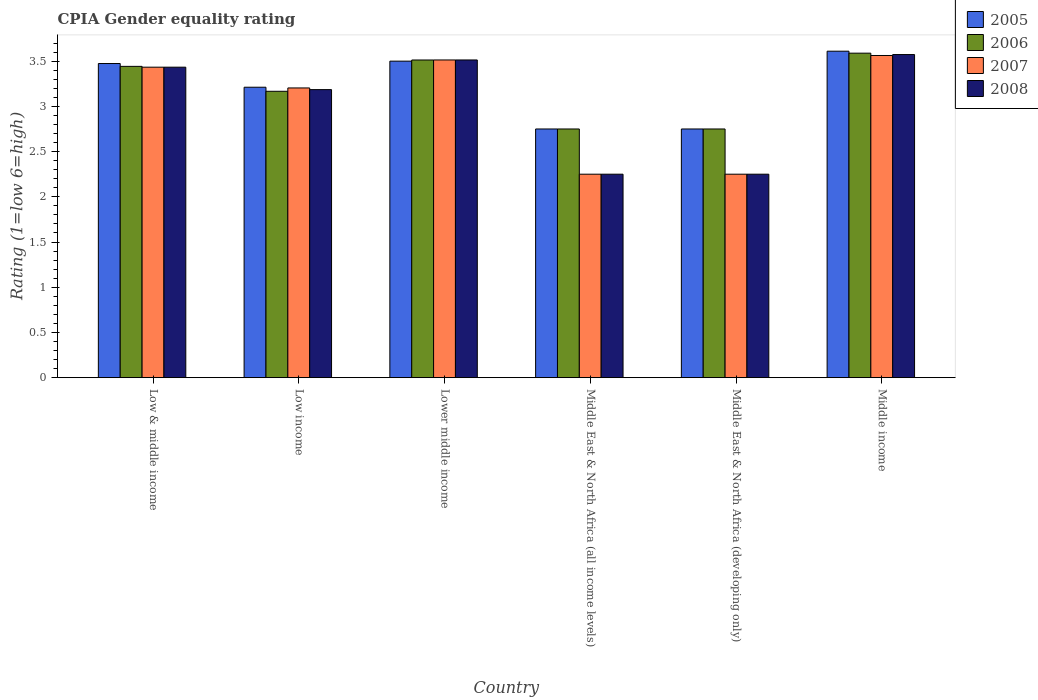How many different coloured bars are there?
Offer a terse response. 4. How many groups of bars are there?
Provide a short and direct response. 6. Are the number of bars per tick equal to the number of legend labels?
Offer a very short reply. Yes. How many bars are there on the 5th tick from the left?
Provide a short and direct response. 4. What is the label of the 2nd group of bars from the left?
Your response must be concise. Low income. What is the CPIA rating in 2006 in Low income?
Give a very brief answer. 3.17. Across all countries, what is the maximum CPIA rating in 2005?
Your response must be concise. 3.61. Across all countries, what is the minimum CPIA rating in 2005?
Offer a very short reply. 2.75. In which country was the CPIA rating in 2007 maximum?
Your answer should be compact. Middle income. In which country was the CPIA rating in 2006 minimum?
Ensure brevity in your answer.  Middle East & North Africa (all income levels). What is the total CPIA rating in 2007 in the graph?
Provide a short and direct response. 18.21. What is the difference between the CPIA rating in 2005 in Lower middle income and that in Middle income?
Provide a short and direct response. -0.11. What is the difference between the CPIA rating in 2007 in Lower middle income and the CPIA rating in 2005 in Middle East & North Africa (developing only)?
Keep it short and to the point. 0.76. What is the average CPIA rating in 2007 per country?
Keep it short and to the point. 3.04. What is the difference between the CPIA rating of/in 2007 and CPIA rating of/in 2006 in Low & middle income?
Give a very brief answer. -0.01. What is the ratio of the CPIA rating in 2007 in Middle East & North Africa (all income levels) to that in Middle income?
Your answer should be compact. 0.63. Is the difference between the CPIA rating in 2007 in Lower middle income and Middle East & North Africa (developing only) greater than the difference between the CPIA rating in 2006 in Lower middle income and Middle East & North Africa (developing only)?
Offer a terse response. Yes. What is the difference between the highest and the second highest CPIA rating in 2008?
Provide a succinct answer. 0.08. What is the difference between the highest and the lowest CPIA rating in 2006?
Your answer should be very brief. 0.84. Is it the case that in every country, the sum of the CPIA rating in 2005 and CPIA rating in 2008 is greater than the sum of CPIA rating in 2006 and CPIA rating in 2007?
Offer a terse response. No. What does the 2nd bar from the left in Middle East & North Africa (all income levels) represents?
Provide a succinct answer. 2006. What does the 3rd bar from the right in Middle East & North Africa (all income levels) represents?
Ensure brevity in your answer.  2006. Is it the case that in every country, the sum of the CPIA rating in 2005 and CPIA rating in 2008 is greater than the CPIA rating in 2006?
Your answer should be very brief. Yes. Are all the bars in the graph horizontal?
Offer a very short reply. No. How many legend labels are there?
Keep it short and to the point. 4. What is the title of the graph?
Offer a terse response. CPIA Gender equality rating. What is the label or title of the X-axis?
Provide a succinct answer. Country. What is the Rating (1=low 6=high) of 2005 in Low & middle income?
Your answer should be very brief. 3.47. What is the Rating (1=low 6=high) of 2006 in Low & middle income?
Provide a short and direct response. 3.44. What is the Rating (1=low 6=high) in 2007 in Low & middle income?
Keep it short and to the point. 3.43. What is the Rating (1=low 6=high) in 2008 in Low & middle income?
Your response must be concise. 3.43. What is the Rating (1=low 6=high) in 2005 in Low income?
Your answer should be compact. 3.21. What is the Rating (1=low 6=high) of 2006 in Low income?
Your answer should be very brief. 3.17. What is the Rating (1=low 6=high) in 2007 in Low income?
Provide a succinct answer. 3.2. What is the Rating (1=low 6=high) in 2008 in Low income?
Provide a short and direct response. 3.19. What is the Rating (1=low 6=high) of 2005 in Lower middle income?
Your response must be concise. 3.5. What is the Rating (1=low 6=high) of 2006 in Lower middle income?
Your answer should be compact. 3.51. What is the Rating (1=low 6=high) in 2007 in Lower middle income?
Ensure brevity in your answer.  3.51. What is the Rating (1=low 6=high) of 2008 in Lower middle income?
Make the answer very short. 3.51. What is the Rating (1=low 6=high) of 2005 in Middle East & North Africa (all income levels)?
Make the answer very short. 2.75. What is the Rating (1=low 6=high) of 2006 in Middle East & North Africa (all income levels)?
Provide a succinct answer. 2.75. What is the Rating (1=low 6=high) of 2007 in Middle East & North Africa (all income levels)?
Your answer should be compact. 2.25. What is the Rating (1=low 6=high) of 2008 in Middle East & North Africa (all income levels)?
Provide a succinct answer. 2.25. What is the Rating (1=low 6=high) in 2005 in Middle East & North Africa (developing only)?
Your answer should be very brief. 2.75. What is the Rating (1=low 6=high) of 2006 in Middle East & North Africa (developing only)?
Your answer should be compact. 2.75. What is the Rating (1=low 6=high) of 2007 in Middle East & North Africa (developing only)?
Provide a succinct answer. 2.25. What is the Rating (1=low 6=high) of 2008 in Middle East & North Africa (developing only)?
Your response must be concise. 2.25. What is the Rating (1=low 6=high) of 2005 in Middle income?
Provide a short and direct response. 3.61. What is the Rating (1=low 6=high) in 2006 in Middle income?
Give a very brief answer. 3.59. What is the Rating (1=low 6=high) of 2007 in Middle income?
Offer a terse response. 3.56. What is the Rating (1=low 6=high) of 2008 in Middle income?
Ensure brevity in your answer.  3.57. Across all countries, what is the maximum Rating (1=low 6=high) of 2005?
Offer a terse response. 3.61. Across all countries, what is the maximum Rating (1=low 6=high) of 2006?
Your answer should be very brief. 3.59. Across all countries, what is the maximum Rating (1=low 6=high) in 2007?
Offer a terse response. 3.56. Across all countries, what is the maximum Rating (1=low 6=high) of 2008?
Your answer should be very brief. 3.57. Across all countries, what is the minimum Rating (1=low 6=high) in 2005?
Give a very brief answer. 2.75. Across all countries, what is the minimum Rating (1=low 6=high) in 2006?
Offer a very short reply. 2.75. Across all countries, what is the minimum Rating (1=low 6=high) of 2007?
Ensure brevity in your answer.  2.25. Across all countries, what is the minimum Rating (1=low 6=high) in 2008?
Provide a succinct answer. 2.25. What is the total Rating (1=low 6=high) of 2005 in the graph?
Your answer should be compact. 19.3. What is the total Rating (1=low 6=high) in 2006 in the graph?
Offer a terse response. 19.21. What is the total Rating (1=low 6=high) of 2007 in the graph?
Provide a short and direct response. 18.21. What is the total Rating (1=low 6=high) in 2008 in the graph?
Provide a succinct answer. 18.2. What is the difference between the Rating (1=low 6=high) of 2005 in Low & middle income and that in Low income?
Keep it short and to the point. 0.26. What is the difference between the Rating (1=low 6=high) of 2006 in Low & middle income and that in Low income?
Your answer should be very brief. 0.28. What is the difference between the Rating (1=low 6=high) of 2007 in Low & middle income and that in Low income?
Provide a short and direct response. 0.23. What is the difference between the Rating (1=low 6=high) in 2008 in Low & middle income and that in Low income?
Provide a succinct answer. 0.25. What is the difference between the Rating (1=low 6=high) in 2005 in Low & middle income and that in Lower middle income?
Offer a very short reply. -0.03. What is the difference between the Rating (1=low 6=high) in 2006 in Low & middle income and that in Lower middle income?
Your answer should be compact. -0.07. What is the difference between the Rating (1=low 6=high) of 2007 in Low & middle income and that in Lower middle income?
Offer a very short reply. -0.08. What is the difference between the Rating (1=low 6=high) of 2008 in Low & middle income and that in Lower middle income?
Provide a short and direct response. -0.08. What is the difference between the Rating (1=low 6=high) of 2005 in Low & middle income and that in Middle East & North Africa (all income levels)?
Provide a short and direct response. 0.72. What is the difference between the Rating (1=low 6=high) of 2006 in Low & middle income and that in Middle East & North Africa (all income levels)?
Keep it short and to the point. 0.69. What is the difference between the Rating (1=low 6=high) in 2007 in Low & middle income and that in Middle East & North Africa (all income levels)?
Your response must be concise. 1.18. What is the difference between the Rating (1=low 6=high) of 2008 in Low & middle income and that in Middle East & North Africa (all income levels)?
Ensure brevity in your answer.  1.18. What is the difference between the Rating (1=low 6=high) of 2005 in Low & middle income and that in Middle East & North Africa (developing only)?
Offer a very short reply. 0.72. What is the difference between the Rating (1=low 6=high) in 2006 in Low & middle income and that in Middle East & North Africa (developing only)?
Your answer should be compact. 0.69. What is the difference between the Rating (1=low 6=high) in 2007 in Low & middle income and that in Middle East & North Africa (developing only)?
Provide a short and direct response. 1.18. What is the difference between the Rating (1=low 6=high) in 2008 in Low & middle income and that in Middle East & North Africa (developing only)?
Offer a very short reply. 1.18. What is the difference between the Rating (1=low 6=high) of 2005 in Low & middle income and that in Middle income?
Make the answer very short. -0.14. What is the difference between the Rating (1=low 6=high) of 2006 in Low & middle income and that in Middle income?
Your response must be concise. -0.15. What is the difference between the Rating (1=low 6=high) of 2007 in Low & middle income and that in Middle income?
Your response must be concise. -0.13. What is the difference between the Rating (1=low 6=high) in 2008 in Low & middle income and that in Middle income?
Keep it short and to the point. -0.14. What is the difference between the Rating (1=low 6=high) of 2005 in Low income and that in Lower middle income?
Your answer should be very brief. -0.29. What is the difference between the Rating (1=low 6=high) in 2006 in Low income and that in Lower middle income?
Ensure brevity in your answer.  -0.35. What is the difference between the Rating (1=low 6=high) of 2007 in Low income and that in Lower middle income?
Keep it short and to the point. -0.31. What is the difference between the Rating (1=low 6=high) of 2008 in Low income and that in Lower middle income?
Your answer should be very brief. -0.33. What is the difference between the Rating (1=low 6=high) of 2005 in Low income and that in Middle East & North Africa (all income levels)?
Your answer should be compact. 0.46. What is the difference between the Rating (1=low 6=high) in 2006 in Low income and that in Middle East & North Africa (all income levels)?
Make the answer very short. 0.42. What is the difference between the Rating (1=low 6=high) in 2007 in Low income and that in Middle East & North Africa (all income levels)?
Make the answer very short. 0.95. What is the difference between the Rating (1=low 6=high) in 2008 in Low income and that in Middle East & North Africa (all income levels)?
Offer a terse response. 0.94. What is the difference between the Rating (1=low 6=high) in 2005 in Low income and that in Middle East & North Africa (developing only)?
Your answer should be compact. 0.46. What is the difference between the Rating (1=low 6=high) of 2006 in Low income and that in Middle East & North Africa (developing only)?
Provide a short and direct response. 0.42. What is the difference between the Rating (1=low 6=high) in 2007 in Low income and that in Middle East & North Africa (developing only)?
Give a very brief answer. 0.95. What is the difference between the Rating (1=low 6=high) of 2008 in Low income and that in Middle East & North Africa (developing only)?
Provide a succinct answer. 0.94. What is the difference between the Rating (1=low 6=high) of 2005 in Low income and that in Middle income?
Your answer should be very brief. -0.4. What is the difference between the Rating (1=low 6=high) in 2006 in Low income and that in Middle income?
Make the answer very short. -0.42. What is the difference between the Rating (1=low 6=high) of 2007 in Low income and that in Middle income?
Your answer should be very brief. -0.36. What is the difference between the Rating (1=low 6=high) of 2008 in Low income and that in Middle income?
Ensure brevity in your answer.  -0.39. What is the difference between the Rating (1=low 6=high) of 2005 in Lower middle income and that in Middle East & North Africa (all income levels)?
Give a very brief answer. 0.75. What is the difference between the Rating (1=low 6=high) in 2006 in Lower middle income and that in Middle East & North Africa (all income levels)?
Your answer should be compact. 0.76. What is the difference between the Rating (1=low 6=high) of 2007 in Lower middle income and that in Middle East & North Africa (all income levels)?
Your answer should be compact. 1.26. What is the difference between the Rating (1=low 6=high) of 2008 in Lower middle income and that in Middle East & North Africa (all income levels)?
Give a very brief answer. 1.26. What is the difference between the Rating (1=low 6=high) in 2005 in Lower middle income and that in Middle East & North Africa (developing only)?
Provide a short and direct response. 0.75. What is the difference between the Rating (1=low 6=high) in 2006 in Lower middle income and that in Middle East & North Africa (developing only)?
Offer a terse response. 0.76. What is the difference between the Rating (1=low 6=high) in 2007 in Lower middle income and that in Middle East & North Africa (developing only)?
Provide a short and direct response. 1.26. What is the difference between the Rating (1=low 6=high) of 2008 in Lower middle income and that in Middle East & North Africa (developing only)?
Provide a short and direct response. 1.26. What is the difference between the Rating (1=low 6=high) of 2005 in Lower middle income and that in Middle income?
Give a very brief answer. -0.11. What is the difference between the Rating (1=low 6=high) of 2006 in Lower middle income and that in Middle income?
Offer a terse response. -0.08. What is the difference between the Rating (1=low 6=high) of 2007 in Lower middle income and that in Middle income?
Your response must be concise. -0.05. What is the difference between the Rating (1=low 6=high) of 2008 in Lower middle income and that in Middle income?
Your answer should be very brief. -0.06. What is the difference between the Rating (1=low 6=high) of 2005 in Middle East & North Africa (all income levels) and that in Middle East & North Africa (developing only)?
Provide a short and direct response. 0. What is the difference between the Rating (1=low 6=high) in 2006 in Middle East & North Africa (all income levels) and that in Middle East & North Africa (developing only)?
Provide a succinct answer. 0. What is the difference between the Rating (1=low 6=high) in 2008 in Middle East & North Africa (all income levels) and that in Middle East & North Africa (developing only)?
Ensure brevity in your answer.  0. What is the difference between the Rating (1=low 6=high) in 2005 in Middle East & North Africa (all income levels) and that in Middle income?
Provide a succinct answer. -0.86. What is the difference between the Rating (1=low 6=high) of 2006 in Middle East & North Africa (all income levels) and that in Middle income?
Your answer should be compact. -0.84. What is the difference between the Rating (1=low 6=high) in 2007 in Middle East & North Africa (all income levels) and that in Middle income?
Your response must be concise. -1.31. What is the difference between the Rating (1=low 6=high) of 2008 in Middle East & North Africa (all income levels) and that in Middle income?
Offer a terse response. -1.32. What is the difference between the Rating (1=low 6=high) of 2005 in Middle East & North Africa (developing only) and that in Middle income?
Your response must be concise. -0.86. What is the difference between the Rating (1=low 6=high) of 2006 in Middle East & North Africa (developing only) and that in Middle income?
Your answer should be compact. -0.84. What is the difference between the Rating (1=low 6=high) of 2007 in Middle East & North Africa (developing only) and that in Middle income?
Your answer should be very brief. -1.31. What is the difference between the Rating (1=low 6=high) in 2008 in Middle East & North Africa (developing only) and that in Middle income?
Your response must be concise. -1.32. What is the difference between the Rating (1=low 6=high) of 2005 in Low & middle income and the Rating (1=low 6=high) of 2006 in Low income?
Offer a terse response. 0.31. What is the difference between the Rating (1=low 6=high) in 2005 in Low & middle income and the Rating (1=low 6=high) in 2007 in Low income?
Make the answer very short. 0.27. What is the difference between the Rating (1=low 6=high) in 2005 in Low & middle income and the Rating (1=low 6=high) in 2008 in Low income?
Provide a short and direct response. 0.29. What is the difference between the Rating (1=low 6=high) in 2006 in Low & middle income and the Rating (1=low 6=high) in 2007 in Low income?
Give a very brief answer. 0.24. What is the difference between the Rating (1=low 6=high) in 2006 in Low & middle income and the Rating (1=low 6=high) in 2008 in Low income?
Make the answer very short. 0.26. What is the difference between the Rating (1=low 6=high) in 2007 in Low & middle income and the Rating (1=low 6=high) in 2008 in Low income?
Your response must be concise. 0.25. What is the difference between the Rating (1=low 6=high) of 2005 in Low & middle income and the Rating (1=low 6=high) of 2006 in Lower middle income?
Provide a short and direct response. -0.04. What is the difference between the Rating (1=low 6=high) in 2005 in Low & middle income and the Rating (1=low 6=high) in 2007 in Lower middle income?
Provide a succinct answer. -0.04. What is the difference between the Rating (1=low 6=high) of 2005 in Low & middle income and the Rating (1=low 6=high) of 2008 in Lower middle income?
Offer a terse response. -0.04. What is the difference between the Rating (1=low 6=high) of 2006 in Low & middle income and the Rating (1=low 6=high) of 2007 in Lower middle income?
Offer a very short reply. -0.07. What is the difference between the Rating (1=low 6=high) in 2006 in Low & middle income and the Rating (1=low 6=high) in 2008 in Lower middle income?
Offer a terse response. -0.07. What is the difference between the Rating (1=low 6=high) in 2007 in Low & middle income and the Rating (1=low 6=high) in 2008 in Lower middle income?
Provide a succinct answer. -0.08. What is the difference between the Rating (1=low 6=high) in 2005 in Low & middle income and the Rating (1=low 6=high) in 2006 in Middle East & North Africa (all income levels)?
Keep it short and to the point. 0.72. What is the difference between the Rating (1=low 6=high) of 2005 in Low & middle income and the Rating (1=low 6=high) of 2007 in Middle East & North Africa (all income levels)?
Your answer should be compact. 1.22. What is the difference between the Rating (1=low 6=high) of 2005 in Low & middle income and the Rating (1=low 6=high) of 2008 in Middle East & North Africa (all income levels)?
Your answer should be compact. 1.22. What is the difference between the Rating (1=low 6=high) in 2006 in Low & middle income and the Rating (1=low 6=high) in 2007 in Middle East & North Africa (all income levels)?
Offer a very short reply. 1.19. What is the difference between the Rating (1=low 6=high) in 2006 in Low & middle income and the Rating (1=low 6=high) in 2008 in Middle East & North Africa (all income levels)?
Provide a short and direct response. 1.19. What is the difference between the Rating (1=low 6=high) of 2007 in Low & middle income and the Rating (1=low 6=high) of 2008 in Middle East & North Africa (all income levels)?
Provide a short and direct response. 1.18. What is the difference between the Rating (1=low 6=high) of 2005 in Low & middle income and the Rating (1=low 6=high) of 2006 in Middle East & North Africa (developing only)?
Keep it short and to the point. 0.72. What is the difference between the Rating (1=low 6=high) of 2005 in Low & middle income and the Rating (1=low 6=high) of 2007 in Middle East & North Africa (developing only)?
Give a very brief answer. 1.22. What is the difference between the Rating (1=low 6=high) of 2005 in Low & middle income and the Rating (1=low 6=high) of 2008 in Middle East & North Africa (developing only)?
Offer a terse response. 1.22. What is the difference between the Rating (1=low 6=high) of 2006 in Low & middle income and the Rating (1=low 6=high) of 2007 in Middle East & North Africa (developing only)?
Offer a very short reply. 1.19. What is the difference between the Rating (1=low 6=high) in 2006 in Low & middle income and the Rating (1=low 6=high) in 2008 in Middle East & North Africa (developing only)?
Ensure brevity in your answer.  1.19. What is the difference between the Rating (1=low 6=high) of 2007 in Low & middle income and the Rating (1=low 6=high) of 2008 in Middle East & North Africa (developing only)?
Make the answer very short. 1.18. What is the difference between the Rating (1=low 6=high) of 2005 in Low & middle income and the Rating (1=low 6=high) of 2006 in Middle income?
Your answer should be very brief. -0.11. What is the difference between the Rating (1=low 6=high) in 2005 in Low & middle income and the Rating (1=low 6=high) in 2007 in Middle income?
Make the answer very short. -0.09. What is the difference between the Rating (1=low 6=high) in 2005 in Low & middle income and the Rating (1=low 6=high) in 2008 in Middle income?
Provide a short and direct response. -0.1. What is the difference between the Rating (1=low 6=high) of 2006 in Low & middle income and the Rating (1=low 6=high) of 2007 in Middle income?
Make the answer very short. -0.12. What is the difference between the Rating (1=low 6=high) of 2006 in Low & middle income and the Rating (1=low 6=high) of 2008 in Middle income?
Provide a succinct answer. -0.13. What is the difference between the Rating (1=low 6=high) in 2007 in Low & middle income and the Rating (1=low 6=high) in 2008 in Middle income?
Give a very brief answer. -0.14. What is the difference between the Rating (1=low 6=high) in 2005 in Low income and the Rating (1=low 6=high) in 2006 in Lower middle income?
Provide a short and direct response. -0.3. What is the difference between the Rating (1=low 6=high) of 2005 in Low income and the Rating (1=low 6=high) of 2007 in Lower middle income?
Your answer should be very brief. -0.3. What is the difference between the Rating (1=low 6=high) in 2005 in Low income and the Rating (1=low 6=high) in 2008 in Lower middle income?
Your response must be concise. -0.3. What is the difference between the Rating (1=low 6=high) in 2006 in Low income and the Rating (1=low 6=high) in 2007 in Lower middle income?
Provide a short and direct response. -0.35. What is the difference between the Rating (1=low 6=high) in 2006 in Low income and the Rating (1=low 6=high) in 2008 in Lower middle income?
Offer a terse response. -0.35. What is the difference between the Rating (1=low 6=high) in 2007 in Low income and the Rating (1=low 6=high) in 2008 in Lower middle income?
Give a very brief answer. -0.31. What is the difference between the Rating (1=low 6=high) of 2005 in Low income and the Rating (1=low 6=high) of 2006 in Middle East & North Africa (all income levels)?
Your answer should be very brief. 0.46. What is the difference between the Rating (1=low 6=high) in 2005 in Low income and the Rating (1=low 6=high) in 2007 in Middle East & North Africa (all income levels)?
Keep it short and to the point. 0.96. What is the difference between the Rating (1=low 6=high) in 2005 in Low income and the Rating (1=low 6=high) in 2008 in Middle East & North Africa (all income levels)?
Give a very brief answer. 0.96. What is the difference between the Rating (1=low 6=high) in 2006 in Low income and the Rating (1=low 6=high) in 2007 in Middle East & North Africa (all income levels)?
Provide a short and direct response. 0.92. What is the difference between the Rating (1=low 6=high) of 2006 in Low income and the Rating (1=low 6=high) of 2008 in Middle East & North Africa (all income levels)?
Provide a succinct answer. 0.92. What is the difference between the Rating (1=low 6=high) in 2007 in Low income and the Rating (1=low 6=high) in 2008 in Middle East & North Africa (all income levels)?
Keep it short and to the point. 0.95. What is the difference between the Rating (1=low 6=high) in 2005 in Low income and the Rating (1=low 6=high) in 2006 in Middle East & North Africa (developing only)?
Your answer should be very brief. 0.46. What is the difference between the Rating (1=low 6=high) of 2005 in Low income and the Rating (1=low 6=high) of 2007 in Middle East & North Africa (developing only)?
Offer a terse response. 0.96. What is the difference between the Rating (1=low 6=high) in 2005 in Low income and the Rating (1=low 6=high) in 2008 in Middle East & North Africa (developing only)?
Make the answer very short. 0.96. What is the difference between the Rating (1=low 6=high) of 2006 in Low income and the Rating (1=low 6=high) of 2007 in Middle East & North Africa (developing only)?
Your response must be concise. 0.92. What is the difference between the Rating (1=low 6=high) of 2007 in Low income and the Rating (1=low 6=high) of 2008 in Middle East & North Africa (developing only)?
Give a very brief answer. 0.95. What is the difference between the Rating (1=low 6=high) of 2005 in Low income and the Rating (1=low 6=high) of 2006 in Middle income?
Give a very brief answer. -0.38. What is the difference between the Rating (1=low 6=high) in 2005 in Low income and the Rating (1=low 6=high) in 2007 in Middle income?
Your answer should be compact. -0.35. What is the difference between the Rating (1=low 6=high) of 2005 in Low income and the Rating (1=low 6=high) of 2008 in Middle income?
Ensure brevity in your answer.  -0.36. What is the difference between the Rating (1=low 6=high) of 2006 in Low income and the Rating (1=low 6=high) of 2007 in Middle income?
Provide a succinct answer. -0.4. What is the difference between the Rating (1=low 6=high) of 2006 in Low income and the Rating (1=low 6=high) of 2008 in Middle income?
Your answer should be compact. -0.41. What is the difference between the Rating (1=low 6=high) in 2007 in Low income and the Rating (1=low 6=high) in 2008 in Middle income?
Provide a short and direct response. -0.37. What is the difference between the Rating (1=low 6=high) in 2005 in Lower middle income and the Rating (1=low 6=high) in 2006 in Middle East & North Africa (all income levels)?
Provide a short and direct response. 0.75. What is the difference between the Rating (1=low 6=high) in 2005 in Lower middle income and the Rating (1=low 6=high) in 2008 in Middle East & North Africa (all income levels)?
Offer a terse response. 1.25. What is the difference between the Rating (1=low 6=high) in 2006 in Lower middle income and the Rating (1=low 6=high) in 2007 in Middle East & North Africa (all income levels)?
Provide a succinct answer. 1.26. What is the difference between the Rating (1=low 6=high) of 2006 in Lower middle income and the Rating (1=low 6=high) of 2008 in Middle East & North Africa (all income levels)?
Give a very brief answer. 1.26. What is the difference between the Rating (1=low 6=high) of 2007 in Lower middle income and the Rating (1=low 6=high) of 2008 in Middle East & North Africa (all income levels)?
Provide a succinct answer. 1.26. What is the difference between the Rating (1=low 6=high) of 2005 in Lower middle income and the Rating (1=low 6=high) of 2006 in Middle East & North Africa (developing only)?
Ensure brevity in your answer.  0.75. What is the difference between the Rating (1=low 6=high) in 2005 in Lower middle income and the Rating (1=low 6=high) in 2008 in Middle East & North Africa (developing only)?
Provide a succinct answer. 1.25. What is the difference between the Rating (1=low 6=high) of 2006 in Lower middle income and the Rating (1=low 6=high) of 2007 in Middle East & North Africa (developing only)?
Give a very brief answer. 1.26. What is the difference between the Rating (1=low 6=high) of 2006 in Lower middle income and the Rating (1=low 6=high) of 2008 in Middle East & North Africa (developing only)?
Your response must be concise. 1.26. What is the difference between the Rating (1=low 6=high) in 2007 in Lower middle income and the Rating (1=low 6=high) in 2008 in Middle East & North Africa (developing only)?
Your answer should be compact. 1.26. What is the difference between the Rating (1=low 6=high) of 2005 in Lower middle income and the Rating (1=low 6=high) of 2006 in Middle income?
Provide a succinct answer. -0.09. What is the difference between the Rating (1=low 6=high) of 2005 in Lower middle income and the Rating (1=low 6=high) of 2007 in Middle income?
Your answer should be compact. -0.06. What is the difference between the Rating (1=low 6=high) in 2005 in Lower middle income and the Rating (1=low 6=high) in 2008 in Middle income?
Your answer should be very brief. -0.07. What is the difference between the Rating (1=low 6=high) of 2006 in Lower middle income and the Rating (1=low 6=high) of 2007 in Middle income?
Offer a very short reply. -0.05. What is the difference between the Rating (1=low 6=high) in 2006 in Lower middle income and the Rating (1=low 6=high) in 2008 in Middle income?
Give a very brief answer. -0.06. What is the difference between the Rating (1=low 6=high) in 2007 in Lower middle income and the Rating (1=low 6=high) in 2008 in Middle income?
Your answer should be very brief. -0.06. What is the difference between the Rating (1=low 6=high) of 2005 in Middle East & North Africa (all income levels) and the Rating (1=low 6=high) of 2006 in Middle East & North Africa (developing only)?
Keep it short and to the point. 0. What is the difference between the Rating (1=low 6=high) of 2005 in Middle East & North Africa (all income levels) and the Rating (1=low 6=high) of 2007 in Middle East & North Africa (developing only)?
Make the answer very short. 0.5. What is the difference between the Rating (1=low 6=high) in 2005 in Middle East & North Africa (all income levels) and the Rating (1=low 6=high) in 2008 in Middle East & North Africa (developing only)?
Provide a succinct answer. 0.5. What is the difference between the Rating (1=low 6=high) in 2006 in Middle East & North Africa (all income levels) and the Rating (1=low 6=high) in 2008 in Middle East & North Africa (developing only)?
Make the answer very short. 0.5. What is the difference between the Rating (1=low 6=high) in 2007 in Middle East & North Africa (all income levels) and the Rating (1=low 6=high) in 2008 in Middle East & North Africa (developing only)?
Ensure brevity in your answer.  0. What is the difference between the Rating (1=low 6=high) of 2005 in Middle East & North Africa (all income levels) and the Rating (1=low 6=high) of 2006 in Middle income?
Make the answer very short. -0.84. What is the difference between the Rating (1=low 6=high) in 2005 in Middle East & North Africa (all income levels) and the Rating (1=low 6=high) in 2007 in Middle income?
Provide a succinct answer. -0.81. What is the difference between the Rating (1=low 6=high) of 2005 in Middle East & North Africa (all income levels) and the Rating (1=low 6=high) of 2008 in Middle income?
Your answer should be compact. -0.82. What is the difference between the Rating (1=low 6=high) in 2006 in Middle East & North Africa (all income levels) and the Rating (1=low 6=high) in 2007 in Middle income?
Offer a very short reply. -0.81. What is the difference between the Rating (1=low 6=high) in 2006 in Middle East & North Africa (all income levels) and the Rating (1=low 6=high) in 2008 in Middle income?
Provide a succinct answer. -0.82. What is the difference between the Rating (1=low 6=high) in 2007 in Middle East & North Africa (all income levels) and the Rating (1=low 6=high) in 2008 in Middle income?
Offer a terse response. -1.32. What is the difference between the Rating (1=low 6=high) in 2005 in Middle East & North Africa (developing only) and the Rating (1=low 6=high) in 2006 in Middle income?
Offer a terse response. -0.84. What is the difference between the Rating (1=low 6=high) of 2005 in Middle East & North Africa (developing only) and the Rating (1=low 6=high) of 2007 in Middle income?
Your response must be concise. -0.81. What is the difference between the Rating (1=low 6=high) in 2005 in Middle East & North Africa (developing only) and the Rating (1=low 6=high) in 2008 in Middle income?
Your response must be concise. -0.82. What is the difference between the Rating (1=low 6=high) in 2006 in Middle East & North Africa (developing only) and the Rating (1=low 6=high) in 2007 in Middle income?
Your response must be concise. -0.81. What is the difference between the Rating (1=low 6=high) of 2006 in Middle East & North Africa (developing only) and the Rating (1=low 6=high) of 2008 in Middle income?
Your answer should be compact. -0.82. What is the difference between the Rating (1=low 6=high) of 2007 in Middle East & North Africa (developing only) and the Rating (1=low 6=high) of 2008 in Middle income?
Keep it short and to the point. -1.32. What is the average Rating (1=low 6=high) in 2005 per country?
Provide a succinct answer. 3.22. What is the average Rating (1=low 6=high) in 2006 per country?
Give a very brief answer. 3.2. What is the average Rating (1=low 6=high) of 2007 per country?
Your answer should be compact. 3.04. What is the average Rating (1=low 6=high) of 2008 per country?
Offer a terse response. 3.03. What is the difference between the Rating (1=low 6=high) in 2005 and Rating (1=low 6=high) in 2006 in Low & middle income?
Offer a terse response. 0.03. What is the difference between the Rating (1=low 6=high) of 2005 and Rating (1=low 6=high) of 2007 in Low & middle income?
Your answer should be compact. 0.04. What is the difference between the Rating (1=low 6=high) in 2005 and Rating (1=low 6=high) in 2008 in Low & middle income?
Ensure brevity in your answer.  0.04. What is the difference between the Rating (1=low 6=high) of 2006 and Rating (1=low 6=high) of 2007 in Low & middle income?
Keep it short and to the point. 0.01. What is the difference between the Rating (1=low 6=high) in 2006 and Rating (1=low 6=high) in 2008 in Low & middle income?
Offer a very short reply. 0.01. What is the difference between the Rating (1=low 6=high) of 2005 and Rating (1=low 6=high) of 2006 in Low income?
Give a very brief answer. 0.04. What is the difference between the Rating (1=low 6=high) of 2005 and Rating (1=low 6=high) of 2007 in Low income?
Your answer should be compact. 0.01. What is the difference between the Rating (1=low 6=high) of 2005 and Rating (1=low 6=high) of 2008 in Low income?
Provide a succinct answer. 0.03. What is the difference between the Rating (1=low 6=high) in 2006 and Rating (1=low 6=high) in 2007 in Low income?
Keep it short and to the point. -0.04. What is the difference between the Rating (1=low 6=high) in 2006 and Rating (1=low 6=high) in 2008 in Low income?
Ensure brevity in your answer.  -0.02. What is the difference between the Rating (1=low 6=high) in 2007 and Rating (1=low 6=high) in 2008 in Low income?
Offer a terse response. 0.02. What is the difference between the Rating (1=low 6=high) in 2005 and Rating (1=low 6=high) in 2006 in Lower middle income?
Provide a short and direct response. -0.01. What is the difference between the Rating (1=low 6=high) of 2005 and Rating (1=low 6=high) of 2007 in Lower middle income?
Make the answer very short. -0.01. What is the difference between the Rating (1=low 6=high) in 2005 and Rating (1=low 6=high) in 2008 in Lower middle income?
Your answer should be very brief. -0.01. What is the difference between the Rating (1=low 6=high) of 2006 and Rating (1=low 6=high) of 2007 in Lower middle income?
Ensure brevity in your answer.  -0. What is the difference between the Rating (1=low 6=high) in 2006 and Rating (1=low 6=high) in 2008 in Lower middle income?
Your response must be concise. -0. What is the difference between the Rating (1=low 6=high) in 2007 and Rating (1=low 6=high) in 2008 in Lower middle income?
Your answer should be compact. 0. What is the difference between the Rating (1=low 6=high) of 2005 and Rating (1=low 6=high) of 2006 in Middle East & North Africa (all income levels)?
Your response must be concise. 0. What is the difference between the Rating (1=low 6=high) of 2007 and Rating (1=low 6=high) of 2008 in Middle East & North Africa (all income levels)?
Offer a very short reply. 0. What is the difference between the Rating (1=low 6=high) in 2005 and Rating (1=low 6=high) in 2006 in Middle East & North Africa (developing only)?
Make the answer very short. 0. What is the difference between the Rating (1=low 6=high) of 2005 and Rating (1=low 6=high) of 2007 in Middle East & North Africa (developing only)?
Your answer should be compact. 0.5. What is the difference between the Rating (1=low 6=high) of 2005 and Rating (1=low 6=high) of 2008 in Middle East & North Africa (developing only)?
Ensure brevity in your answer.  0.5. What is the difference between the Rating (1=low 6=high) of 2007 and Rating (1=low 6=high) of 2008 in Middle East & North Africa (developing only)?
Offer a very short reply. 0. What is the difference between the Rating (1=low 6=high) in 2005 and Rating (1=low 6=high) in 2006 in Middle income?
Your response must be concise. 0.02. What is the difference between the Rating (1=low 6=high) in 2005 and Rating (1=low 6=high) in 2007 in Middle income?
Give a very brief answer. 0.05. What is the difference between the Rating (1=low 6=high) in 2005 and Rating (1=low 6=high) in 2008 in Middle income?
Your answer should be compact. 0.04. What is the difference between the Rating (1=low 6=high) in 2006 and Rating (1=low 6=high) in 2007 in Middle income?
Give a very brief answer. 0.03. What is the difference between the Rating (1=low 6=high) in 2006 and Rating (1=low 6=high) in 2008 in Middle income?
Offer a very short reply. 0.02. What is the difference between the Rating (1=low 6=high) in 2007 and Rating (1=low 6=high) in 2008 in Middle income?
Your answer should be very brief. -0.01. What is the ratio of the Rating (1=low 6=high) of 2005 in Low & middle income to that in Low income?
Your response must be concise. 1.08. What is the ratio of the Rating (1=low 6=high) in 2006 in Low & middle income to that in Low income?
Provide a succinct answer. 1.09. What is the ratio of the Rating (1=low 6=high) in 2007 in Low & middle income to that in Low income?
Your answer should be very brief. 1.07. What is the ratio of the Rating (1=low 6=high) in 2008 in Low & middle income to that in Low income?
Ensure brevity in your answer.  1.08. What is the ratio of the Rating (1=low 6=high) in 2005 in Low & middle income to that in Lower middle income?
Your answer should be compact. 0.99. What is the ratio of the Rating (1=low 6=high) of 2006 in Low & middle income to that in Lower middle income?
Your answer should be very brief. 0.98. What is the ratio of the Rating (1=low 6=high) in 2007 in Low & middle income to that in Lower middle income?
Your response must be concise. 0.98. What is the ratio of the Rating (1=low 6=high) of 2008 in Low & middle income to that in Lower middle income?
Keep it short and to the point. 0.98. What is the ratio of the Rating (1=low 6=high) of 2005 in Low & middle income to that in Middle East & North Africa (all income levels)?
Give a very brief answer. 1.26. What is the ratio of the Rating (1=low 6=high) of 2006 in Low & middle income to that in Middle East & North Africa (all income levels)?
Your answer should be very brief. 1.25. What is the ratio of the Rating (1=low 6=high) of 2007 in Low & middle income to that in Middle East & North Africa (all income levels)?
Your response must be concise. 1.53. What is the ratio of the Rating (1=low 6=high) in 2008 in Low & middle income to that in Middle East & North Africa (all income levels)?
Your answer should be compact. 1.53. What is the ratio of the Rating (1=low 6=high) in 2005 in Low & middle income to that in Middle East & North Africa (developing only)?
Your answer should be compact. 1.26. What is the ratio of the Rating (1=low 6=high) in 2006 in Low & middle income to that in Middle East & North Africa (developing only)?
Offer a very short reply. 1.25. What is the ratio of the Rating (1=low 6=high) in 2007 in Low & middle income to that in Middle East & North Africa (developing only)?
Ensure brevity in your answer.  1.53. What is the ratio of the Rating (1=low 6=high) in 2008 in Low & middle income to that in Middle East & North Africa (developing only)?
Give a very brief answer. 1.53. What is the ratio of the Rating (1=low 6=high) of 2005 in Low & middle income to that in Middle income?
Keep it short and to the point. 0.96. What is the ratio of the Rating (1=low 6=high) of 2006 in Low & middle income to that in Middle income?
Make the answer very short. 0.96. What is the ratio of the Rating (1=low 6=high) in 2007 in Low & middle income to that in Middle income?
Ensure brevity in your answer.  0.96. What is the ratio of the Rating (1=low 6=high) in 2008 in Low & middle income to that in Middle income?
Give a very brief answer. 0.96. What is the ratio of the Rating (1=low 6=high) in 2005 in Low income to that in Lower middle income?
Provide a short and direct response. 0.92. What is the ratio of the Rating (1=low 6=high) of 2006 in Low income to that in Lower middle income?
Provide a succinct answer. 0.9. What is the ratio of the Rating (1=low 6=high) of 2007 in Low income to that in Lower middle income?
Your response must be concise. 0.91. What is the ratio of the Rating (1=low 6=high) in 2008 in Low income to that in Lower middle income?
Keep it short and to the point. 0.91. What is the ratio of the Rating (1=low 6=high) of 2005 in Low income to that in Middle East & North Africa (all income levels)?
Provide a short and direct response. 1.17. What is the ratio of the Rating (1=low 6=high) of 2006 in Low income to that in Middle East & North Africa (all income levels)?
Your answer should be very brief. 1.15. What is the ratio of the Rating (1=low 6=high) of 2007 in Low income to that in Middle East & North Africa (all income levels)?
Your response must be concise. 1.42. What is the ratio of the Rating (1=low 6=high) of 2008 in Low income to that in Middle East & North Africa (all income levels)?
Make the answer very short. 1.42. What is the ratio of the Rating (1=low 6=high) of 2005 in Low income to that in Middle East & North Africa (developing only)?
Your response must be concise. 1.17. What is the ratio of the Rating (1=low 6=high) of 2006 in Low income to that in Middle East & North Africa (developing only)?
Keep it short and to the point. 1.15. What is the ratio of the Rating (1=low 6=high) in 2007 in Low income to that in Middle East & North Africa (developing only)?
Keep it short and to the point. 1.42. What is the ratio of the Rating (1=low 6=high) of 2008 in Low income to that in Middle East & North Africa (developing only)?
Ensure brevity in your answer.  1.42. What is the ratio of the Rating (1=low 6=high) of 2005 in Low income to that in Middle income?
Offer a very short reply. 0.89. What is the ratio of the Rating (1=low 6=high) of 2006 in Low income to that in Middle income?
Your answer should be compact. 0.88. What is the ratio of the Rating (1=low 6=high) in 2007 in Low income to that in Middle income?
Your answer should be compact. 0.9. What is the ratio of the Rating (1=low 6=high) in 2008 in Low income to that in Middle income?
Provide a short and direct response. 0.89. What is the ratio of the Rating (1=low 6=high) of 2005 in Lower middle income to that in Middle East & North Africa (all income levels)?
Provide a short and direct response. 1.27. What is the ratio of the Rating (1=low 6=high) of 2006 in Lower middle income to that in Middle East & North Africa (all income levels)?
Give a very brief answer. 1.28. What is the ratio of the Rating (1=low 6=high) of 2007 in Lower middle income to that in Middle East & North Africa (all income levels)?
Provide a short and direct response. 1.56. What is the ratio of the Rating (1=low 6=high) in 2008 in Lower middle income to that in Middle East & North Africa (all income levels)?
Make the answer very short. 1.56. What is the ratio of the Rating (1=low 6=high) in 2005 in Lower middle income to that in Middle East & North Africa (developing only)?
Provide a succinct answer. 1.27. What is the ratio of the Rating (1=low 6=high) in 2006 in Lower middle income to that in Middle East & North Africa (developing only)?
Ensure brevity in your answer.  1.28. What is the ratio of the Rating (1=low 6=high) of 2007 in Lower middle income to that in Middle East & North Africa (developing only)?
Offer a very short reply. 1.56. What is the ratio of the Rating (1=low 6=high) in 2008 in Lower middle income to that in Middle East & North Africa (developing only)?
Your response must be concise. 1.56. What is the ratio of the Rating (1=low 6=high) in 2005 in Lower middle income to that in Middle income?
Ensure brevity in your answer.  0.97. What is the ratio of the Rating (1=low 6=high) in 2007 in Lower middle income to that in Middle income?
Provide a succinct answer. 0.99. What is the ratio of the Rating (1=low 6=high) of 2008 in Lower middle income to that in Middle income?
Offer a very short reply. 0.98. What is the ratio of the Rating (1=low 6=high) in 2005 in Middle East & North Africa (all income levels) to that in Middle East & North Africa (developing only)?
Make the answer very short. 1. What is the ratio of the Rating (1=low 6=high) in 2006 in Middle East & North Africa (all income levels) to that in Middle East & North Africa (developing only)?
Your answer should be very brief. 1. What is the ratio of the Rating (1=low 6=high) of 2007 in Middle East & North Africa (all income levels) to that in Middle East & North Africa (developing only)?
Your response must be concise. 1. What is the ratio of the Rating (1=low 6=high) in 2005 in Middle East & North Africa (all income levels) to that in Middle income?
Give a very brief answer. 0.76. What is the ratio of the Rating (1=low 6=high) of 2006 in Middle East & North Africa (all income levels) to that in Middle income?
Your answer should be very brief. 0.77. What is the ratio of the Rating (1=low 6=high) in 2007 in Middle East & North Africa (all income levels) to that in Middle income?
Your answer should be compact. 0.63. What is the ratio of the Rating (1=low 6=high) in 2008 in Middle East & North Africa (all income levels) to that in Middle income?
Provide a succinct answer. 0.63. What is the ratio of the Rating (1=low 6=high) of 2005 in Middle East & North Africa (developing only) to that in Middle income?
Ensure brevity in your answer.  0.76. What is the ratio of the Rating (1=low 6=high) of 2006 in Middle East & North Africa (developing only) to that in Middle income?
Provide a succinct answer. 0.77. What is the ratio of the Rating (1=low 6=high) in 2007 in Middle East & North Africa (developing only) to that in Middle income?
Provide a succinct answer. 0.63. What is the ratio of the Rating (1=low 6=high) in 2008 in Middle East & North Africa (developing only) to that in Middle income?
Offer a very short reply. 0.63. What is the difference between the highest and the second highest Rating (1=low 6=high) in 2005?
Make the answer very short. 0.11. What is the difference between the highest and the second highest Rating (1=low 6=high) of 2006?
Your answer should be compact. 0.08. What is the difference between the highest and the second highest Rating (1=low 6=high) of 2007?
Give a very brief answer. 0.05. What is the difference between the highest and the second highest Rating (1=low 6=high) in 2008?
Your answer should be compact. 0.06. What is the difference between the highest and the lowest Rating (1=low 6=high) in 2005?
Keep it short and to the point. 0.86. What is the difference between the highest and the lowest Rating (1=low 6=high) in 2006?
Your response must be concise. 0.84. What is the difference between the highest and the lowest Rating (1=low 6=high) in 2007?
Provide a succinct answer. 1.31. What is the difference between the highest and the lowest Rating (1=low 6=high) of 2008?
Provide a short and direct response. 1.32. 